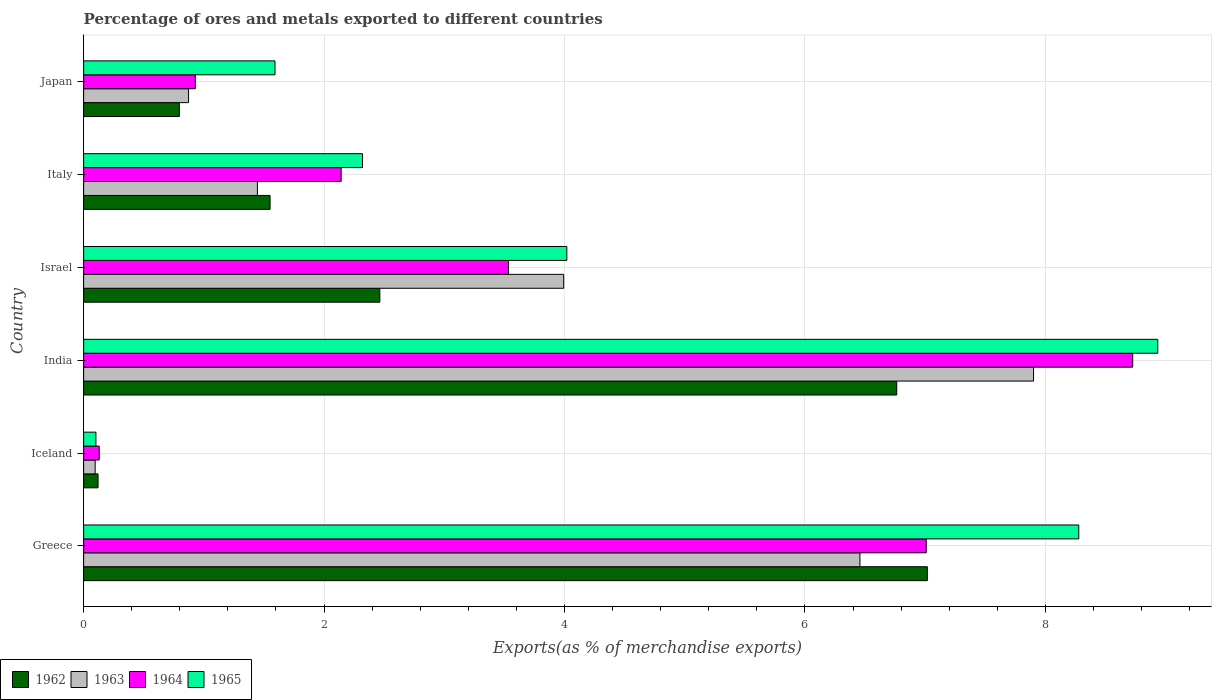How many different coloured bars are there?
Offer a very short reply. 4. How many groups of bars are there?
Provide a succinct answer. 6. Are the number of bars per tick equal to the number of legend labels?
Your response must be concise. Yes. Are the number of bars on each tick of the Y-axis equal?
Keep it short and to the point. Yes. How many bars are there on the 6th tick from the top?
Ensure brevity in your answer.  4. How many bars are there on the 2nd tick from the bottom?
Offer a terse response. 4. In how many cases, is the number of bars for a given country not equal to the number of legend labels?
Keep it short and to the point. 0. What is the percentage of exports to different countries in 1964 in Greece?
Your response must be concise. 7.01. Across all countries, what is the maximum percentage of exports to different countries in 1963?
Provide a succinct answer. 7.9. Across all countries, what is the minimum percentage of exports to different countries in 1964?
Make the answer very short. 0.13. In which country was the percentage of exports to different countries in 1964 maximum?
Provide a short and direct response. India. In which country was the percentage of exports to different countries in 1963 minimum?
Your answer should be compact. Iceland. What is the total percentage of exports to different countries in 1962 in the graph?
Provide a short and direct response. 18.71. What is the difference between the percentage of exports to different countries in 1962 in Greece and that in India?
Your answer should be very brief. 0.26. What is the difference between the percentage of exports to different countries in 1963 in Italy and the percentage of exports to different countries in 1965 in Iceland?
Ensure brevity in your answer.  1.34. What is the average percentage of exports to different countries in 1963 per country?
Provide a short and direct response. 3.46. What is the difference between the percentage of exports to different countries in 1965 and percentage of exports to different countries in 1963 in Iceland?
Offer a very short reply. 0.01. What is the ratio of the percentage of exports to different countries in 1964 in Greece to that in Iceland?
Give a very brief answer. 54.09. Is the difference between the percentage of exports to different countries in 1965 in Iceland and Israel greater than the difference between the percentage of exports to different countries in 1963 in Iceland and Israel?
Offer a very short reply. No. What is the difference between the highest and the second highest percentage of exports to different countries in 1965?
Provide a succinct answer. 0.66. What is the difference between the highest and the lowest percentage of exports to different countries in 1965?
Give a very brief answer. 8.83. In how many countries, is the percentage of exports to different countries in 1964 greater than the average percentage of exports to different countries in 1964 taken over all countries?
Provide a succinct answer. 2. Is it the case that in every country, the sum of the percentage of exports to different countries in 1963 and percentage of exports to different countries in 1962 is greater than the sum of percentage of exports to different countries in 1965 and percentage of exports to different countries in 1964?
Provide a succinct answer. No. What does the 2nd bar from the bottom in Iceland represents?
Give a very brief answer. 1963. How many countries are there in the graph?
Offer a terse response. 6. What is the difference between two consecutive major ticks on the X-axis?
Offer a very short reply. 2. Does the graph contain grids?
Offer a very short reply. Yes. How many legend labels are there?
Keep it short and to the point. 4. How are the legend labels stacked?
Ensure brevity in your answer.  Horizontal. What is the title of the graph?
Your answer should be compact. Percentage of ores and metals exported to different countries. Does "1972" appear as one of the legend labels in the graph?
Your response must be concise. No. What is the label or title of the X-axis?
Your response must be concise. Exports(as % of merchandise exports). What is the Exports(as % of merchandise exports) of 1962 in Greece?
Ensure brevity in your answer.  7.02. What is the Exports(as % of merchandise exports) of 1963 in Greece?
Keep it short and to the point. 6.46. What is the Exports(as % of merchandise exports) in 1964 in Greece?
Offer a terse response. 7.01. What is the Exports(as % of merchandise exports) of 1965 in Greece?
Give a very brief answer. 8.28. What is the Exports(as % of merchandise exports) of 1962 in Iceland?
Ensure brevity in your answer.  0.12. What is the Exports(as % of merchandise exports) of 1963 in Iceland?
Your answer should be very brief. 0.1. What is the Exports(as % of merchandise exports) of 1964 in Iceland?
Provide a succinct answer. 0.13. What is the Exports(as % of merchandise exports) of 1965 in Iceland?
Offer a very short reply. 0.1. What is the Exports(as % of merchandise exports) of 1962 in India?
Keep it short and to the point. 6.76. What is the Exports(as % of merchandise exports) in 1963 in India?
Offer a very short reply. 7.9. What is the Exports(as % of merchandise exports) in 1964 in India?
Your answer should be compact. 8.73. What is the Exports(as % of merchandise exports) in 1965 in India?
Offer a very short reply. 8.94. What is the Exports(as % of merchandise exports) of 1962 in Israel?
Provide a succinct answer. 2.46. What is the Exports(as % of merchandise exports) in 1963 in Israel?
Offer a terse response. 3.99. What is the Exports(as % of merchandise exports) in 1964 in Israel?
Your answer should be compact. 3.53. What is the Exports(as % of merchandise exports) in 1965 in Israel?
Your answer should be compact. 4.02. What is the Exports(as % of merchandise exports) in 1962 in Italy?
Keep it short and to the point. 1.55. What is the Exports(as % of merchandise exports) in 1963 in Italy?
Offer a terse response. 1.45. What is the Exports(as % of merchandise exports) of 1964 in Italy?
Provide a succinct answer. 2.14. What is the Exports(as % of merchandise exports) of 1965 in Italy?
Offer a terse response. 2.32. What is the Exports(as % of merchandise exports) of 1962 in Japan?
Your answer should be compact. 0.8. What is the Exports(as % of merchandise exports) of 1963 in Japan?
Provide a succinct answer. 0.87. What is the Exports(as % of merchandise exports) of 1964 in Japan?
Ensure brevity in your answer.  0.93. What is the Exports(as % of merchandise exports) of 1965 in Japan?
Provide a succinct answer. 1.59. Across all countries, what is the maximum Exports(as % of merchandise exports) in 1962?
Provide a succinct answer. 7.02. Across all countries, what is the maximum Exports(as % of merchandise exports) in 1963?
Make the answer very short. 7.9. Across all countries, what is the maximum Exports(as % of merchandise exports) in 1964?
Ensure brevity in your answer.  8.73. Across all countries, what is the maximum Exports(as % of merchandise exports) of 1965?
Your response must be concise. 8.94. Across all countries, what is the minimum Exports(as % of merchandise exports) of 1962?
Your answer should be compact. 0.12. Across all countries, what is the minimum Exports(as % of merchandise exports) in 1963?
Ensure brevity in your answer.  0.1. Across all countries, what is the minimum Exports(as % of merchandise exports) of 1964?
Provide a short and direct response. 0.13. Across all countries, what is the minimum Exports(as % of merchandise exports) in 1965?
Your answer should be very brief. 0.1. What is the total Exports(as % of merchandise exports) of 1962 in the graph?
Keep it short and to the point. 18.71. What is the total Exports(as % of merchandise exports) of 1963 in the graph?
Your answer should be compact. 20.77. What is the total Exports(as % of merchandise exports) in 1964 in the graph?
Offer a very short reply. 22.47. What is the total Exports(as % of merchandise exports) of 1965 in the graph?
Offer a very short reply. 25.25. What is the difference between the Exports(as % of merchandise exports) of 1962 in Greece and that in Iceland?
Make the answer very short. 6.9. What is the difference between the Exports(as % of merchandise exports) of 1963 in Greece and that in Iceland?
Make the answer very short. 6.36. What is the difference between the Exports(as % of merchandise exports) of 1964 in Greece and that in Iceland?
Provide a short and direct response. 6.88. What is the difference between the Exports(as % of merchandise exports) in 1965 in Greece and that in Iceland?
Your response must be concise. 8.18. What is the difference between the Exports(as % of merchandise exports) in 1962 in Greece and that in India?
Make the answer very short. 0.26. What is the difference between the Exports(as % of merchandise exports) of 1963 in Greece and that in India?
Your answer should be compact. -1.44. What is the difference between the Exports(as % of merchandise exports) in 1964 in Greece and that in India?
Your answer should be compact. -1.72. What is the difference between the Exports(as % of merchandise exports) in 1965 in Greece and that in India?
Give a very brief answer. -0.66. What is the difference between the Exports(as % of merchandise exports) of 1962 in Greece and that in Israel?
Provide a short and direct response. 4.55. What is the difference between the Exports(as % of merchandise exports) in 1963 in Greece and that in Israel?
Your answer should be very brief. 2.46. What is the difference between the Exports(as % of merchandise exports) in 1964 in Greece and that in Israel?
Provide a succinct answer. 3.48. What is the difference between the Exports(as % of merchandise exports) of 1965 in Greece and that in Israel?
Provide a short and direct response. 4.26. What is the difference between the Exports(as % of merchandise exports) in 1962 in Greece and that in Italy?
Your answer should be very brief. 5.47. What is the difference between the Exports(as % of merchandise exports) of 1963 in Greece and that in Italy?
Provide a succinct answer. 5.01. What is the difference between the Exports(as % of merchandise exports) in 1964 in Greece and that in Italy?
Your answer should be compact. 4.87. What is the difference between the Exports(as % of merchandise exports) of 1965 in Greece and that in Italy?
Offer a terse response. 5.96. What is the difference between the Exports(as % of merchandise exports) in 1962 in Greece and that in Japan?
Give a very brief answer. 6.22. What is the difference between the Exports(as % of merchandise exports) of 1963 in Greece and that in Japan?
Ensure brevity in your answer.  5.58. What is the difference between the Exports(as % of merchandise exports) in 1964 in Greece and that in Japan?
Ensure brevity in your answer.  6.08. What is the difference between the Exports(as % of merchandise exports) in 1965 in Greece and that in Japan?
Provide a short and direct response. 6.69. What is the difference between the Exports(as % of merchandise exports) of 1962 in Iceland and that in India?
Ensure brevity in your answer.  -6.64. What is the difference between the Exports(as % of merchandise exports) of 1963 in Iceland and that in India?
Keep it short and to the point. -7.81. What is the difference between the Exports(as % of merchandise exports) of 1964 in Iceland and that in India?
Provide a succinct answer. -8.6. What is the difference between the Exports(as % of merchandise exports) of 1965 in Iceland and that in India?
Keep it short and to the point. -8.83. What is the difference between the Exports(as % of merchandise exports) in 1962 in Iceland and that in Israel?
Offer a very short reply. -2.34. What is the difference between the Exports(as % of merchandise exports) in 1963 in Iceland and that in Israel?
Your answer should be compact. -3.9. What is the difference between the Exports(as % of merchandise exports) of 1964 in Iceland and that in Israel?
Give a very brief answer. -3.4. What is the difference between the Exports(as % of merchandise exports) in 1965 in Iceland and that in Israel?
Offer a terse response. -3.92. What is the difference between the Exports(as % of merchandise exports) in 1962 in Iceland and that in Italy?
Your answer should be compact. -1.43. What is the difference between the Exports(as % of merchandise exports) in 1963 in Iceland and that in Italy?
Your answer should be compact. -1.35. What is the difference between the Exports(as % of merchandise exports) of 1964 in Iceland and that in Italy?
Your response must be concise. -2.01. What is the difference between the Exports(as % of merchandise exports) in 1965 in Iceland and that in Italy?
Ensure brevity in your answer.  -2.22. What is the difference between the Exports(as % of merchandise exports) of 1962 in Iceland and that in Japan?
Give a very brief answer. -0.68. What is the difference between the Exports(as % of merchandise exports) of 1963 in Iceland and that in Japan?
Give a very brief answer. -0.78. What is the difference between the Exports(as % of merchandise exports) of 1964 in Iceland and that in Japan?
Your answer should be compact. -0.8. What is the difference between the Exports(as % of merchandise exports) in 1965 in Iceland and that in Japan?
Offer a very short reply. -1.49. What is the difference between the Exports(as % of merchandise exports) in 1962 in India and that in Israel?
Offer a very short reply. 4.3. What is the difference between the Exports(as % of merchandise exports) of 1963 in India and that in Israel?
Provide a short and direct response. 3.91. What is the difference between the Exports(as % of merchandise exports) in 1964 in India and that in Israel?
Offer a terse response. 5.19. What is the difference between the Exports(as % of merchandise exports) of 1965 in India and that in Israel?
Keep it short and to the point. 4.92. What is the difference between the Exports(as % of merchandise exports) in 1962 in India and that in Italy?
Keep it short and to the point. 5.21. What is the difference between the Exports(as % of merchandise exports) of 1963 in India and that in Italy?
Your response must be concise. 6.46. What is the difference between the Exports(as % of merchandise exports) of 1964 in India and that in Italy?
Offer a terse response. 6.58. What is the difference between the Exports(as % of merchandise exports) in 1965 in India and that in Italy?
Ensure brevity in your answer.  6.62. What is the difference between the Exports(as % of merchandise exports) of 1962 in India and that in Japan?
Provide a short and direct response. 5.97. What is the difference between the Exports(as % of merchandise exports) of 1963 in India and that in Japan?
Give a very brief answer. 7.03. What is the difference between the Exports(as % of merchandise exports) in 1964 in India and that in Japan?
Your response must be concise. 7.8. What is the difference between the Exports(as % of merchandise exports) of 1965 in India and that in Japan?
Your answer should be compact. 7.34. What is the difference between the Exports(as % of merchandise exports) of 1963 in Israel and that in Italy?
Offer a very short reply. 2.55. What is the difference between the Exports(as % of merchandise exports) in 1964 in Israel and that in Italy?
Make the answer very short. 1.39. What is the difference between the Exports(as % of merchandise exports) of 1965 in Israel and that in Italy?
Offer a very short reply. 1.7. What is the difference between the Exports(as % of merchandise exports) of 1962 in Israel and that in Japan?
Provide a succinct answer. 1.67. What is the difference between the Exports(as % of merchandise exports) of 1963 in Israel and that in Japan?
Offer a terse response. 3.12. What is the difference between the Exports(as % of merchandise exports) of 1964 in Israel and that in Japan?
Your answer should be very brief. 2.6. What is the difference between the Exports(as % of merchandise exports) of 1965 in Israel and that in Japan?
Your answer should be very brief. 2.43. What is the difference between the Exports(as % of merchandise exports) in 1962 in Italy and that in Japan?
Give a very brief answer. 0.75. What is the difference between the Exports(as % of merchandise exports) in 1963 in Italy and that in Japan?
Provide a short and direct response. 0.57. What is the difference between the Exports(as % of merchandise exports) of 1964 in Italy and that in Japan?
Make the answer very short. 1.21. What is the difference between the Exports(as % of merchandise exports) of 1965 in Italy and that in Japan?
Ensure brevity in your answer.  0.73. What is the difference between the Exports(as % of merchandise exports) of 1962 in Greece and the Exports(as % of merchandise exports) of 1963 in Iceland?
Make the answer very short. 6.92. What is the difference between the Exports(as % of merchandise exports) in 1962 in Greece and the Exports(as % of merchandise exports) in 1964 in Iceland?
Provide a succinct answer. 6.89. What is the difference between the Exports(as % of merchandise exports) of 1962 in Greece and the Exports(as % of merchandise exports) of 1965 in Iceland?
Provide a short and direct response. 6.92. What is the difference between the Exports(as % of merchandise exports) in 1963 in Greece and the Exports(as % of merchandise exports) in 1964 in Iceland?
Offer a very short reply. 6.33. What is the difference between the Exports(as % of merchandise exports) in 1963 in Greece and the Exports(as % of merchandise exports) in 1965 in Iceland?
Provide a succinct answer. 6.36. What is the difference between the Exports(as % of merchandise exports) of 1964 in Greece and the Exports(as % of merchandise exports) of 1965 in Iceland?
Offer a terse response. 6.91. What is the difference between the Exports(as % of merchandise exports) in 1962 in Greece and the Exports(as % of merchandise exports) in 1963 in India?
Your response must be concise. -0.88. What is the difference between the Exports(as % of merchandise exports) in 1962 in Greece and the Exports(as % of merchandise exports) in 1964 in India?
Keep it short and to the point. -1.71. What is the difference between the Exports(as % of merchandise exports) in 1962 in Greece and the Exports(as % of merchandise exports) in 1965 in India?
Your answer should be very brief. -1.92. What is the difference between the Exports(as % of merchandise exports) of 1963 in Greece and the Exports(as % of merchandise exports) of 1964 in India?
Give a very brief answer. -2.27. What is the difference between the Exports(as % of merchandise exports) of 1963 in Greece and the Exports(as % of merchandise exports) of 1965 in India?
Your response must be concise. -2.48. What is the difference between the Exports(as % of merchandise exports) in 1964 in Greece and the Exports(as % of merchandise exports) in 1965 in India?
Offer a very short reply. -1.93. What is the difference between the Exports(as % of merchandise exports) of 1962 in Greece and the Exports(as % of merchandise exports) of 1963 in Israel?
Your answer should be compact. 3.03. What is the difference between the Exports(as % of merchandise exports) of 1962 in Greece and the Exports(as % of merchandise exports) of 1964 in Israel?
Give a very brief answer. 3.48. What is the difference between the Exports(as % of merchandise exports) of 1962 in Greece and the Exports(as % of merchandise exports) of 1965 in Israel?
Keep it short and to the point. 3. What is the difference between the Exports(as % of merchandise exports) in 1963 in Greece and the Exports(as % of merchandise exports) in 1964 in Israel?
Provide a succinct answer. 2.92. What is the difference between the Exports(as % of merchandise exports) in 1963 in Greece and the Exports(as % of merchandise exports) in 1965 in Israel?
Keep it short and to the point. 2.44. What is the difference between the Exports(as % of merchandise exports) in 1964 in Greece and the Exports(as % of merchandise exports) in 1965 in Israel?
Your response must be concise. 2.99. What is the difference between the Exports(as % of merchandise exports) in 1962 in Greece and the Exports(as % of merchandise exports) in 1963 in Italy?
Your answer should be very brief. 5.57. What is the difference between the Exports(as % of merchandise exports) in 1962 in Greece and the Exports(as % of merchandise exports) in 1964 in Italy?
Make the answer very short. 4.88. What is the difference between the Exports(as % of merchandise exports) in 1962 in Greece and the Exports(as % of merchandise exports) in 1965 in Italy?
Ensure brevity in your answer.  4.7. What is the difference between the Exports(as % of merchandise exports) of 1963 in Greece and the Exports(as % of merchandise exports) of 1964 in Italy?
Provide a short and direct response. 4.32. What is the difference between the Exports(as % of merchandise exports) of 1963 in Greece and the Exports(as % of merchandise exports) of 1965 in Italy?
Provide a short and direct response. 4.14. What is the difference between the Exports(as % of merchandise exports) in 1964 in Greece and the Exports(as % of merchandise exports) in 1965 in Italy?
Make the answer very short. 4.69. What is the difference between the Exports(as % of merchandise exports) of 1962 in Greece and the Exports(as % of merchandise exports) of 1963 in Japan?
Provide a short and direct response. 6.15. What is the difference between the Exports(as % of merchandise exports) of 1962 in Greece and the Exports(as % of merchandise exports) of 1964 in Japan?
Ensure brevity in your answer.  6.09. What is the difference between the Exports(as % of merchandise exports) in 1962 in Greece and the Exports(as % of merchandise exports) in 1965 in Japan?
Provide a succinct answer. 5.43. What is the difference between the Exports(as % of merchandise exports) in 1963 in Greece and the Exports(as % of merchandise exports) in 1964 in Japan?
Ensure brevity in your answer.  5.53. What is the difference between the Exports(as % of merchandise exports) in 1963 in Greece and the Exports(as % of merchandise exports) in 1965 in Japan?
Your answer should be compact. 4.87. What is the difference between the Exports(as % of merchandise exports) of 1964 in Greece and the Exports(as % of merchandise exports) of 1965 in Japan?
Provide a short and direct response. 5.42. What is the difference between the Exports(as % of merchandise exports) of 1962 in Iceland and the Exports(as % of merchandise exports) of 1963 in India?
Give a very brief answer. -7.78. What is the difference between the Exports(as % of merchandise exports) of 1962 in Iceland and the Exports(as % of merchandise exports) of 1964 in India?
Provide a succinct answer. -8.61. What is the difference between the Exports(as % of merchandise exports) in 1962 in Iceland and the Exports(as % of merchandise exports) in 1965 in India?
Your response must be concise. -8.82. What is the difference between the Exports(as % of merchandise exports) in 1963 in Iceland and the Exports(as % of merchandise exports) in 1964 in India?
Make the answer very short. -8.63. What is the difference between the Exports(as % of merchandise exports) in 1963 in Iceland and the Exports(as % of merchandise exports) in 1965 in India?
Your response must be concise. -8.84. What is the difference between the Exports(as % of merchandise exports) of 1964 in Iceland and the Exports(as % of merchandise exports) of 1965 in India?
Your answer should be compact. -8.81. What is the difference between the Exports(as % of merchandise exports) of 1962 in Iceland and the Exports(as % of merchandise exports) of 1963 in Israel?
Offer a very short reply. -3.87. What is the difference between the Exports(as % of merchandise exports) of 1962 in Iceland and the Exports(as % of merchandise exports) of 1964 in Israel?
Your answer should be very brief. -3.41. What is the difference between the Exports(as % of merchandise exports) of 1962 in Iceland and the Exports(as % of merchandise exports) of 1965 in Israel?
Offer a terse response. -3.9. What is the difference between the Exports(as % of merchandise exports) of 1963 in Iceland and the Exports(as % of merchandise exports) of 1964 in Israel?
Give a very brief answer. -3.44. What is the difference between the Exports(as % of merchandise exports) in 1963 in Iceland and the Exports(as % of merchandise exports) in 1965 in Israel?
Provide a succinct answer. -3.92. What is the difference between the Exports(as % of merchandise exports) of 1964 in Iceland and the Exports(as % of merchandise exports) of 1965 in Israel?
Provide a succinct answer. -3.89. What is the difference between the Exports(as % of merchandise exports) in 1962 in Iceland and the Exports(as % of merchandise exports) in 1963 in Italy?
Provide a short and direct response. -1.33. What is the difference between the Exports(as % of merchandise exports) in 1962 in Iceland and the Exports(as % of merchandise exports) in 1964 in Italy?
Keep it short and to the point. -2.02. What is the difference between the Exports(as % of merchandise exports) of 1962 in Iceland and the Exports(as % of merchandise exports) of 1965 in Italy?
Your response must be concise. -2.2. What is the difference between the Exports(as % of merchandise exports) in 1963 in Iceland and the Exports(as % of merchandise exports) in 1964 in Italy?
Your answer should be compact. -2.05. What is the difference between the Exports(as % of merchandise exports) of 1963 in Iceland and the Exports(as % of merchandise exports) of 1965 in Italy?
Your response must be concise. -2.22. What is the difference between the Exports(as % of merchandise exports) in 1964 in Iceland and the Exports(as % of merchandise exports) in 1965 in Italy?
Your answer should be very brief. -2.19. What is the difference between the Exports(as % of merchandise exports) of 1962 in Iceland and the Exports(as % of merchandise exports) of 1963 in Japan?
Provide a short and direct response. -0.75. What is the difference between the Exports(as % of merchandise exports) in 1962 in Iceland and the Exports(as % of merchandise exports) in 1964 in Japan?
Ensure brevity in your answer.  -0.81. What is the difference between the Exports(as % of merchandise exports) in 1962 in Iceland and the Exports(as % of merchandise exports) in 1965 in Japan?
Keep it short and to the point. -1.47. What is the difference between the Exports(as % of merchandise exports) of 1963 in Iceland and the Exports(as % of merchandise exports) of 1964 in Japan?
Give a very brief answer. -0.83. What is the difference between the Exports(as % of merchandise exports) of 1963 in Iceland and the Exports(as % of merchandise exports) of 1965 in Japan?
Keep it short and to the point. -1.5. What is the difference between the Exports(as % of merchandise exports) in 1964 in Iceland and the Exports(as % of merchandise exports) in 1965 in Japan?
Your answer should be very brief. -1.46. What is the difference between the Exports(as % of merchandise exports) in 1962 in India and the Exports(as % of merchandise exports) in 1963 in Israel?
Ensure brevity in your answer.  2.77. What is the difference between the Exports(as % of merchandise exports) of 1962 in India and the Exports(as % of merchandise exports) of 1964 in Israel?
Provide a succinct answer. 3.23. What is the difference between the Exports(as % of merchandise exports) in 1962 in India and the Exports(as % of merchandise exports) in 1965 in Israel?
Your response must be concise. 2.74. What is the difference between the Exports(as % of merchandise exports) in 1963 in India and the Exports(as % of merchandise exports) in 1964 in Israel?
Ensure brevity in your answer.  4.37. What is the difference between the Exports(as % of merchandise exports) of 1963 in India and the Exports(as % of merchandise exports) of 1965 in Israel?
Provide a succinct answer. 3.88. What is the difference between the Exports(as % of merchandise exports) in 1964 in India and the Exports(as % of merchandise exports) in 1965 in Israel?
Give a very brief answer. 4.71. What is the difference between the Exports(as % of merchandise exports) of 1962 in India and the Exports(as % of merchandise exports) of 1963 in Italy?
Provide a succinct answer. 5.32. What is the difference between the Exports(as % of merchandise exports) of 1962 in India and the Exports(as % of merchandise exports) of 1964 in Italy?
Your answer should be compact. 4.62. What is the difference between the Exports(as % of merchandise exports) of 1962 in India and the Exports(as % of merchandise exports) of 1965 in Italy?
Your answer should be very brief. 4.44. What is the difference between the Exports(as % of merchandise exports) in 1963 in India and the Exports(as % of merchandise exports) in 1964 in Italy?
Keep it short and to the point. 5.76. What is the difference between the Exports(as % of merchandise exports) in 1963 in India and the Exports(as % of merchandise exports) in 1965 in Italy?
Ensure brevity in your answer.  5.58. What is the difference between the Exports(as % of merchandise exports) in 1964 in India and the Exports(as % of merchandise exports) in 1965 in Italy?
Your response must be concise. 6.41. What is the difference between the Exports(as % of merchandise exports) of 1962 in India and the Exports(as % of merchandise exports) of 1963 in Japan?
Your response must be concise. 5.89. What is the difference between the Exports(as % of merchandise exports) in 1962 in India and the Exports(as % of merchandise exports) in 1964 in Japan?
Your response must be concise. 5.83. What is the difference between the Exports(as % of merchandise exports) in 1962 in India and the Exports(as % of merchandise exports) in 1965 in Japan?
Make the answer very short. 5.17. What is the difference between the Exports(as % of merchandise exports) in 1963 in India and the Exports(as % of merchandise exports) in 1964 in Japan?
Your answer should be very brief. 6.97. What is the difference between the Exports(as % of merchandise exports) of 1963 in India and the Exports(as % of merchandise exports) of 1965 in Japan?
Provide a short and direct response. 6.31. What is the difference between the Exports(as % of merchandise exports) of 1964 in India and the Exports(as % of merchandise exports) of 1965 in Japan?
Offer a very short reply. 7.13. What is the difference between the Exports(as % of merchandise exports) of 1962 in Israel and the Exports(as % of merchandise exports) of 1963 in Italy?
Your response must be concise. 1.02. What is the difference between the Exports(as % of merchandise exports) of 1962 in Israel and the Exports(as % of merchandise exports) of 1964 in Italy?
Provide a succinct answer. 0.32. What is the difference between the Exports(as % of merchandise exports) of 1962 in Israel and the Exports(as % of merchandise exports) of 1965 in Italy?
Provide a succinct answer. 0.14. What is the difference between the Exports(as % of merchandise exports) in 1963 in Israel and the Exports(as % of merchandise exports) in 1964 in Italy?
Give a very brief answer. 1.85. What is the difference between the Exports(as % of merchandise exports) of 1963 in Israel and the Exports(as % of merchandise exports) of 1965 in Italy?
Keep it short and to the point. 1.67. What is the difference between the Exports(as % of merchandise exports) in 1964 in Israel and the Exports(as % of merchandise exports) in 1965 in Italy?
Keep it short and to the point. 1.21. What is the difference between the Exports(as % of merchandise exports) of 1962 in Israel and the Exports(as % of merchandise exports) of 1963 in Japan?
Keep it short and to the point. 1.59. What is the difference between the Exports(as % of merchandise exports) in 1962 in Israel and the Exports(as % of merchandise exports) in 1964 in Japan?
Your answer should be very brief. 1.53. What is the difference between the Exports(as % of merchandise exports) of 1962 in Israel and the Exports(as % of merchandise exports) of 1965 in Japan?
Ensure brevity in your answer.  0.87. What is the difference between the Exports(as % of merchandise exports) in 1963 in Israel and the Exports(as % of merchandise exports) in 1964 in Japan?
Your answer should be compact. 3.06. What is the difference between the Exports(as % of merchandise exports) in 1963 in Israel and the Exports(as % of merchandise exports) in 1965 in Japan?
Provide a short and direct response. 2.4. What is the difference between the Exports(as % of merchandise exports) of 1964 in Israel and the Exports(as % of merchandise exports) of 1965 in Japan?
Offer a very short reply. 1.94. What is the difference between the Exports(as % of merchandise exports) of 1962 in Italy and the Exports(as % of merchandise exports) of 1963 in Japan?
Make the answer very short. 0.68. What is the difference between the Exports(as % of merchandise exports) of 1962 in Italy and the Exports(as % of merchandise exports) of 1964 in Japan?
Give a very brief answer. 0.62. What is the difference between the Exports(as % of merchandise exports) in 1962 in Italy and the Exports(as % of merchandise exports) in 1965 in Japan?
Offer a terse response. -0.04. What is the difference between the Exports(as % of merchandise exports) in 1963 in Italy and the Exports(as % of merchandise exports) in 1964 in Japan?
Your response must be concise. 0.52. What is the difference between the Exports(as % of merchandise exports) in 1963 in Italy and the Exports(as % of merchandise exports) in 1965 in Japan?
Your response must be concise. -0.15. What is the difference between the Exports(as % of merchandise exports) in 1964 in Italy and the Exports(as % of merchandise exports) in 1965 in Japan?
Make the answer very short. 0.55. What is the average Exports(as % of merchandise exports) in 1962 per country?
Your answer should be very brief. 3.12. What is the average Exports(as % of merchandise exports) of 1963 per country?
Offer a terse response. 3.46. What is the average Exports(as % of merchandise exports) of 1964 per country?
Ensure brevity in your answer.  3.75. What is the average Exports(as % of merchandise exports) of 1965 per country?
Keep it short and to the point. 4.21. What is the difference between the Exports(as % of merchandise exports) in 1962 and Exports(as % of merchandise exports) in 1963 in Greece?
Provide a short and direct response. 0.56. What is the difference between the Exports(as % of merchandise exports) in 1962 and Exports(as % of merchandise exports) in 1964 in Greece?
Ensure brevity in your answer.  0.01. What is the difference between the Exports(as % of merchandise exports) in 1962 and Exports(as % of merchandise exports) in 1965 in Greece?
Keep it short and to the point. -1.26. What is the difference between the Exports(as % of merchandise exports) of 1963 and Exports(as % of merchandise exports) of 1964 in Greece?
Ensure brevity in your answer.  -0.55. What is the difference between the Exports(as % of merchandise exports) of 1963 and Exports(as % of merchandise exports) of 1965 in Greece?
Your answer should be very brief. -1.82. What is the difference between the Exports(as % of merchandise exports) in 1964 and Exports(as % of merchandise exports) in 1965 in Greece?
Offer a terse response. -1.27. What is the difference between the Exports(as % of merchandise exports) of 1962 and Exports(as % of merchandise exports) of 1963 in Iceland?
Your response must be concise. 0.02. What is the difference between the Exports(as % of merchandise exports) of 1962 and Exports(as % of merchandise exports) of 1964 in Iceland?
Make the answer very short. -0.01. What is the difference between the Exports(as % of merchandise exports) of 1962 and Exports(as % of merchandise exports) of 1965 in Iceland?
Your answer should be compact. 0.02. What is the difference between the Exports(as % of merchandise exports) of 1963 and Exports(as % of merchandise exports) of 1964 in Iceland?
Offer a very short reply. -0.03. What is the difference between the Exports(as % of merchandise exports) of 1963 and Exports(as % of merchandise exports) of 1965 in Iceland?
Offer a terse response. -0.01. What is the difference between the Exports(as % of merchandise exports) in 1964 and Exports(as % of merchandise exports) in 1965 in Iceland?
Your answer should be compact. 0.03. What is the difference between the Exports(as % of merchandise exports) of 1962 and Exports(as % of merchandise exports) of 1963 in India?
Provide a short and direct response. -1.14. What is the difference between the Exports(as % of merchandise exports) in 1962 and Exports(as % of merchandise exports) in 1964 in India?
Give a very brief answer. -1.96. What is the difference between the Exports(as % of merchandise exports) in 1962 and Exports(as % of merchandise exports) in 1965 in India?
Give a very brief answer. -2.17. What is the difference between the Exports(as % of merchandise exports) of 1963 and Exports(as % of merchandise exports) of 1964 in India?
Give a very brief answer. -0.82. What is the difference between the Exports(as % of merchandise exports) in 1963 and Exports(as % of merchandise exports) in 1965 in India?
Keep it short and to the point. -1.03. What is the difference between the Exports(as % of merchandise exports) of 1964 and Exports(as % of merchandise exports) of 1965 in India?
Offer a terse response. -0.21. What is the difference between the Exports(as % of merchandise exports) of 1962 and Exports(as % of merchandise exports) of 1963 in Israel?
Keep it short and to the point. -1.53. What is the difference between the Exports(as % of merchandise exports) of 1962 and Exports(as % of merchandise exports) of 1964 in Israel?
Your answer should be very brief. -1.07. What is the difference between the Exports(as % of merchandise exports) of 1962 and Exports(as % of merchandise exports) of 1965 in Israel?
Keep it short and to the point. -1.56. What is the difference between the Exports(as % of merchandise exports) of 1963 and Exports(as % of merchandise exports) of 1964 in Israel?
Your answer should be very brief. 0.46. What is the difference between the Exports(as % of merchandise exports) of 1963 and Exports(as % of merchandise exports) of 1965 in Israel?
Make the answer very short. -0.03. What is the difference between the Exports(as % of merchandise exports) in 1964 and Exports(as % of merchandise exports) in 1965 in Israel?
Give a very brief answer. -0.49. What is the difference between the Exports(as % of merchandise exports) in 1962 and Exports(as % of merchandise exports) in 1963 in Italy?
Your response must be concise. 0.11. What is the difference between the Exports(as % of merchandise exports) in 1962 and Exports(as % of merchandise exports) in 1964 in Italy?
Your answer should be very brief. -0.59. What is the difference between the Exports(as % of merchandise exports) in 1962 and Exports(as % of merchandise exports) in 1965 in Italy?
Make the answer very short. -0.77. What is the difference between the Exports(as % of merchandise exports) in 1963 and Exports(as % of merchandise exports) in 1964 in Italy?
Ensure brevity in your answer.  -0.7. What is the difference between the Exports(as % of merchandise exports) of 1963 and Exports(as % of merchandise exports) of 1965 in Italy?
Provide a succinct answer. -0.87. What is the difference between the Exports(as % of merchandise exports) in 1964 and Exports(as % of merchandise exports) in 1965 in Italy?
Make the answer very short. -0.18. What is the difference between the Exports(as % of merchandise exports) of 1962 and Exports(as % of merchandise exports) of 1963 in Japan?
Give a very brief answer. -0.08. What is the difference between the Exports(as % of merchandise exports) of 1962 and Exports(as % of merchandise exports) of 1964 in Japan?
Offer a very short reply. -0.13. What is the difference between the Exports(as % of merchandise exports) of 1962 and Exports(as % of merchandise exports) of 1965 in Japan?
Provide a succinct answer. -0.8. What is the difference between the Exports(as % of merchandise exports) of 1963 and Exports(as % of merchandise exports) of 1964 in Japan?
Your response must be concise. -0.06. What is the difference between the Exports(as % of merchandise exports) of 1963 and Exports(as % of merchandise exports) of 1965 in Japan?
Your answer should be compact. -0.72. What is the difference between the Exports(as % of merchandise exports) in 1964 and Exports(as % of merchandise exports) in 1965 in Japan?
Give a very brief answer. -0.66. What is the ratio of the Exports(as % of merchandise exports) in 1962 in Greece to that in Iceland?
Your answer should be compact. 58.51. What is the ratio of the Exports(as % of merchandise exports) in 1963 in Greece to that in Iceland?
Your response must be concise. 67.38. What is the ratio of the Exports(as % of merchandise exports) of 1964 in Greece to that in Iceland?
Keep it short and to the point. 54.09. What is the ratio of the Exports(as % of merchandise exports) in 1965 in Greece to that in Iceland?
Make the answer very short. 81.09. What is the ratio of the Exports(as % of merchandise exports) in 1962 in Greece to that in India?
Ensure brevity in your answer.  1.04. What is the ratio of the Exports(as % of merchandise exports) in 1963 in Greece to that in India?
Your answer should be very brief. 0.82. What is the ratio of the Exports(as % of merchandise exports) in 1964 in Greece to that in India?
Keep it short and to the point. 0.8. What is the ratio of the Exports(as % of merchandise exports) in 1965 in Greece to that in India?
Offer a terse response. 0.93. What is the ratio of the Exports(as % of merchandise exports) of 1962 in Greece to that in Israel?
Provide a succinct answer. 2.85. What is the ratio of the Exports(as % of merchandise exports) in 1963 in Greece to that in Israel?
Make the answer very short. 1.62. What is the ratio of the Exports(as % of merchandise exports) of 1964 in Greece to that in Israel?
Provide a succinct answer. 1.98. What is the ratio of the Exports(as % of merchandise exports) in 1965 in Greece to that in Israel?
Provide a succinct answer. 2.06. What is the ratio of the Exports(as % of merchandise exports) in 1962 in Greece to that in Italy?
Your answer should be compact. 4.53. What is the ratio of the Exports(as % of merchandise exports) of 1963 in Greece to that in Italy?
Your answer should be compact. 4.47. What is the ratio of the Exports(as % of merchandise exports) of 1964 in Greece to that in Italy?
Provide a short and direct response. 3.27. What is the ratio of the Exports(as % of merchandise exports) of 1965 in Greece to that in Italy?
Your answer should be compact. 3.57. What is the ratio of the Exports(as % of merchandise exports) of 1962 in Greece to that in Japan?
Provide a succinct answer. 8.81. What is the ratio of the Exports(as % of merchandise exports) in 1963 in Greece to that in Japan?
Your answer should be very brief. 7.4. What is the ratio of the Exports(as % of merchandise exports) in 1964 in Greece to that in Japan?
Your response must be concise. 7.54. What is the ratio of the Exports(as % of merchandise exports) in 1965 in Greece to that in Japan?
Provide a short and direct response. 5.2. What is the ratio of the Exports(as % of merchandise exports) of 1962 in Iceland to that in India?
Your response must be concise. 0.02. What is the ratio of the Exports(as % of merchandise exports) in 1963 in Iceland to that in India?
Provide a succinct answer. 0.01. What is the ratio of the Exports(as % of merchandise exports) of 1964 in Iceland to that in India?
Your response must be concise. 0.01. What is the ratio of the Exports(as % of merchandise exports) in 1965 in Iceland to that in India?
Provide a short and direct response. 0.01. What is the ratio of the Exports(as % of merchandise exports) of 1962 in Iceland to that in Israel?
Your answer should be compact. 0.05. What is the ratio of the Exports(as % of merchandise exports) of 1963 in Iceland to that in Israel?
Your answer should be compact. 0.02. What is the ratio of the Exports(as % of merchandise exports) of 1964 in Iceland to that in Israel?
Provide a succinct answer. 0.04. What is the ratio of the Exports(as % of merchandise exports) of 1965 in Iceland to that in Israel?
Your response must be concise. 0.03. What is the ratio of the Exports(as % of merchandise exports) of 1962 in Iceland to that in Italy?
Offer a very short reply. 0.08. What is the ratio of the Exports(as % of merchandise exports) in 1963 in Iceland to that in Italy?
Make the answer very short. 0.07. What is the ratio of the Exports(as % of merchandise exports) of 1964 in Iceland to that in Italy?
Provide a short and direct response. 0.06. What is the ratio of the Exports(as % of merchandise exports) of 1965 in Iceland to that in Italy?
Your answer should be compact. 0.04. What is the ratio of the Exports(as % of merchandise exports) of 1962 in Iceland to that in Japan?
Your answer should be compact. 0.15. What is the ratio of the Exports(as % of merchandise exports) in 1963 in Iceland to that in Japan?
Your response must be concise. 0.11. What is the ratio of the Exports(as % of merchandise exports) in 1964 in Iceland to that in Japan?
Provide a short and direct response. 0.14. What is the ratio of the Exports(as % of merchandise exports) of 1965 in Iceland to that in Japan?
Offer a very short reply. 0.06. What is the ratio of the Exports(as % of merchandise exports) in 1962 in India to that in Israel?
Your answer should be very brief. 2.75. What is the ratio of the Exports(as % of merchandise exports) in 1963 in India to that in Israel?
Provide a succinct answer. 1.98. What is the ratio of the Exports(as % of merchandise exports) of 1964 in India to that in Israel?
Your answer should be compact. 2.47. What is the ratio of the Exports(as % of merchandise exports) in 1965 in India to that in Israel?
Make the answer very short. 2.22. What is the ratio of the Exports(as % of merchandise exports) in 1962 in India to that in Italy?
Give a very brief answer. 4.36. What is the ratio of the Exports(as % of merchandise exports) in 1963 in India to that in Italy?
Provide a succinct answer. 5.47. What is the ratio of the Exports(as % of merchandise exports) in 1964 in India to that in Italy?
Your response must be concise. 4.07. What is the ratio of the Exports(as % of merchandise exports) of 1965 in India to that in Italy?
Your answer should be very brief. 3.85. What is the ratio of the Exports(as % of merchandise exports) in 1962 in India to that in Japan?
Give a very brief answer. 8.49. What is the ratio of the Exports(as % of merchandise exports) in 1963 in India to that in Japan?
Offer a very short reply. 9.05. What is the ratio of the Exports(as % of merchandise exports) in 1964 in India to that in Japan?
Offer a very short reply. 9.39. What is the ratio of the Exports(as % of merchandise exports) in 1965 in India to that in Japan?
Ensure brevity in your answer.  5.61. What is the ratio of the Exports(as % of merchandise exports) of 1962 in Israel to that in Italy?
Give a very brief answer. 1.59. What is the ratio of the Exports(as % of merchandise exports) of 1963 in Israel to that in Italy?
Provide a short and direct response. 2.76. What is the ratio of the Exports(as % of merchandise exports) of 1964 in Israel to that in Italy?
Give a very brief answer. 1.65. What is the ratio of the Exports(as % of merchandise exports) in 1965 in Israel to that in Italy?
Your response must be concise. 1.73. What is the ratio of the Exports(as % of merchandise exports) of 1962 in Israel to that in Japan?
Your answer should be very brief. 3.09. What is the ratio of the Exports(as % of merchandise exports) of 1963 in Israel to that in Japan?
Provide a succinct answer. 4.57. What is the ratio of the Exports(as % of merchandise exports) of 1964 in Israel to that in Japan?
Give a very brief answer. 3.8. What is the ratio of the Exports(as % of merchandise exports) of 1965 in Israel to that in Japan?
Your answer should be very brief. 2.52. What is the ratio of the Exports(as % of merchandise exports) in 1962 in Italy to that in Japan?
Give a very brief answer. 1.95. What is the ratio of the Exports(as % of merchandise exports) in 1963 in Italy to that in Japan?
Offer a terse response. 1.66. What is the ratio of the Exports(as % of merchandise exports) in 1964 in Italy to that in Japan?
Your answer should be compact. 2.31. What is the ratio of the Exports(as % of merchandise exports) of 1965 in Italy to that in Japan?
Ensure brevity in your answer.  1.46. What is the difference between the highest and the second highest Exports(as % of merchandise exports) of 1962?
Offer a terse response. 0.26. What is the difference between the highest and the second highest Exports(as % of merchandise exports) of 1963?
Keep it short and to the point. 1.44. What is the difference between the highest and the second highest Exports(as % of merchandise exports) of 1964?
Offer a very short reply. 1.72. What is the difference between the highest and the second highest Exports(as % of merchandise exports) of 1965?
Give a very brief answer. 0.66. What is the difference between the highest and the lowest Exports(as % of merchandise exports) in 1962?
Keep it short and to the point. 6.9. What is the difference between the highest and the lowest Exports(as % of merchandise exports) of 1963?
Your answer should be very brief. 7.81. What is the difference between the highest and the lowest Exports(as % of merchandise exports) in 1964?
Make the answer very short. 8.6. What is the difference between the highest and the lowest Exports(as % of merchandise exports) in 1965?
Your answer should be very brief. 8.83. 